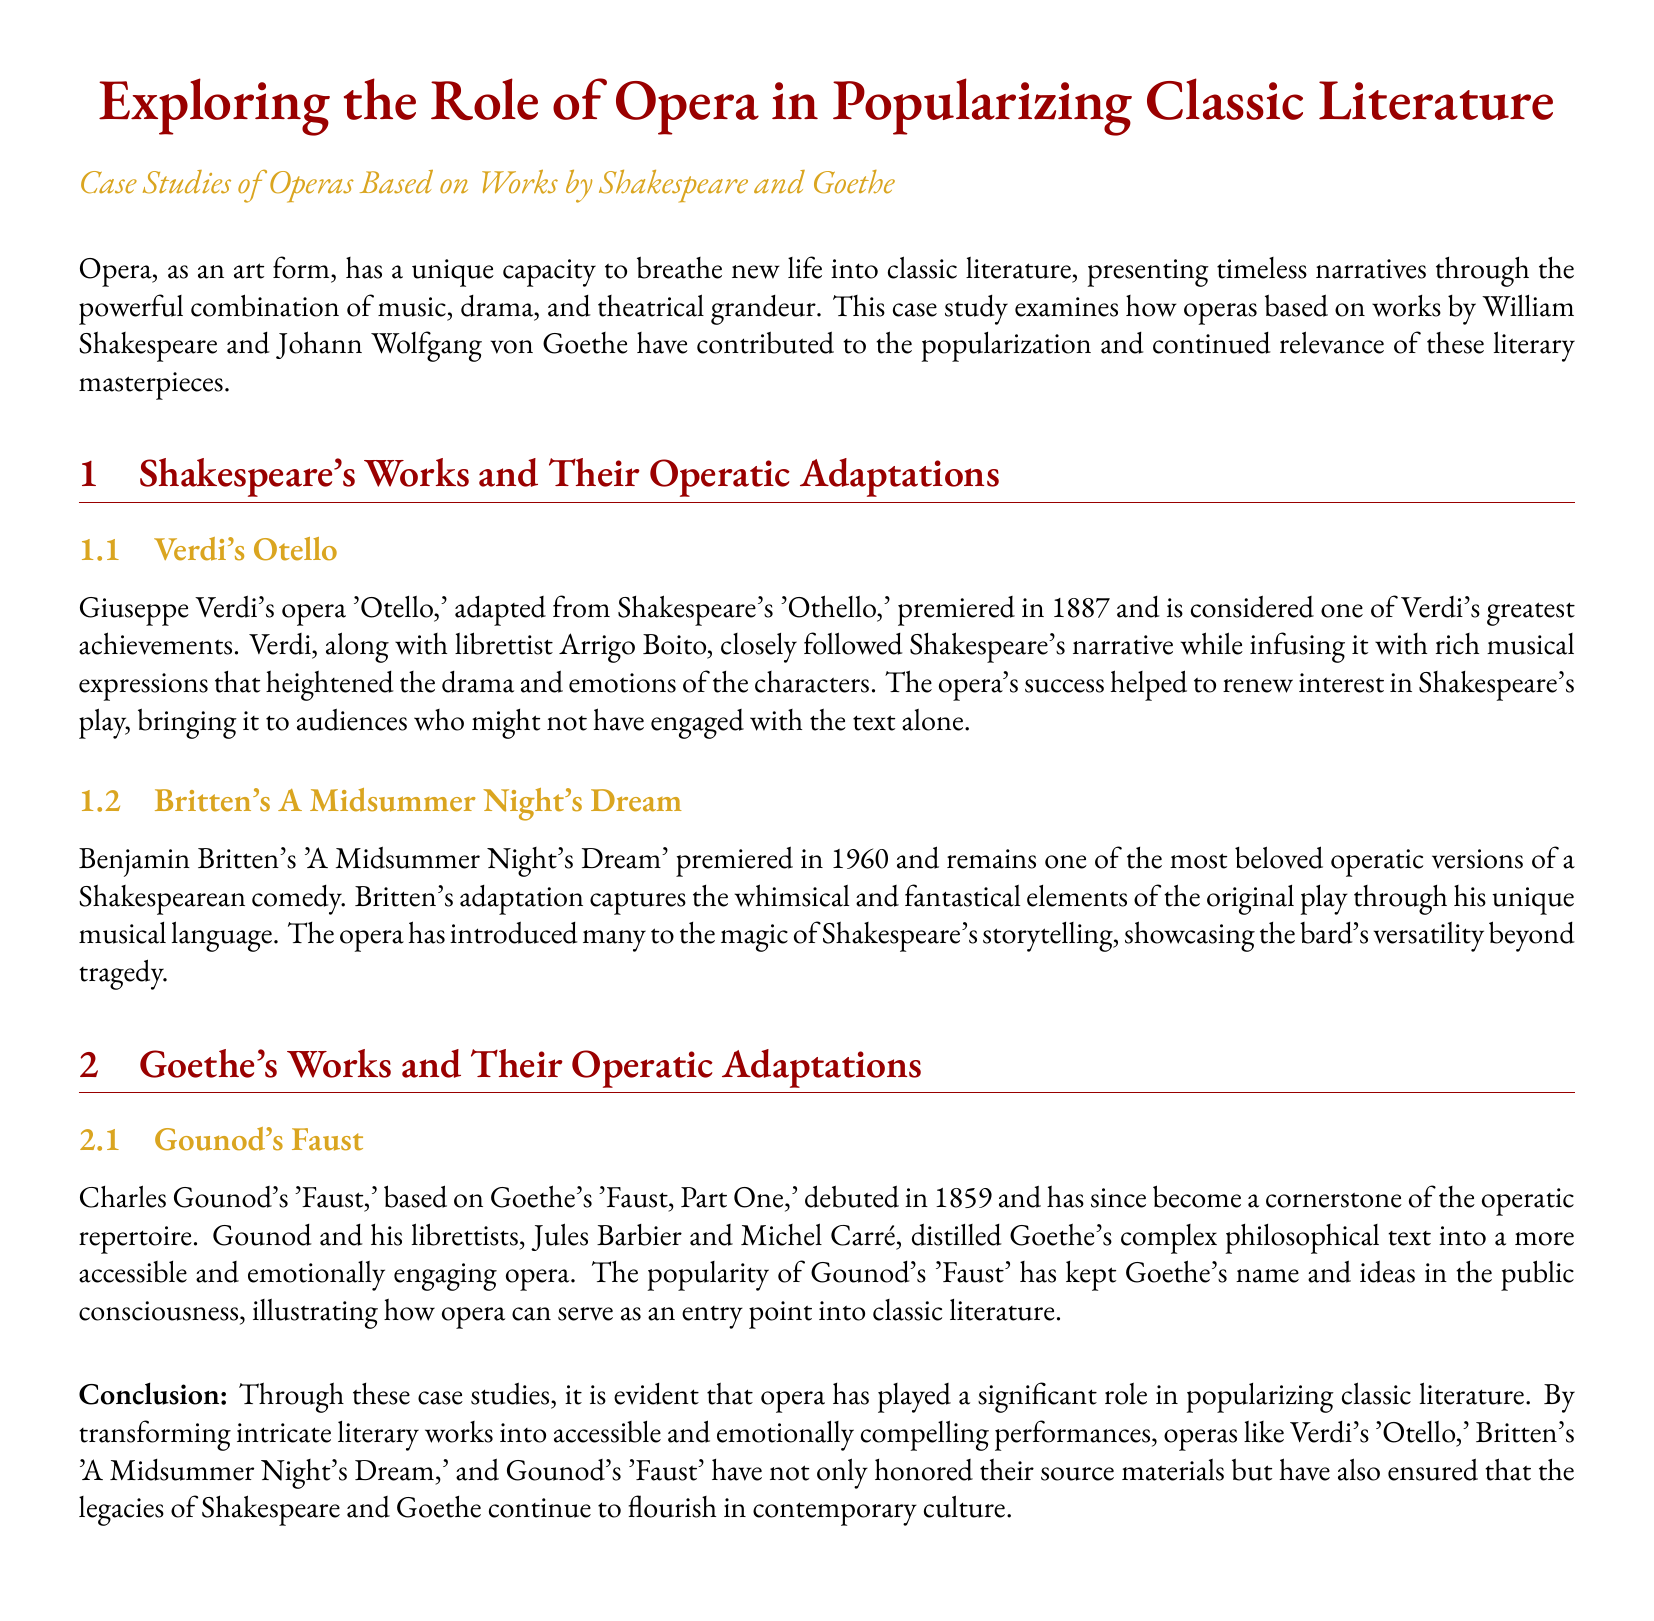What is the title of Verdi's opera adapted from Shakespeare? The title of Verdi's opera is 'Otello,' which is adapted from Shakespeare's 'Othello.'
Answer: 'Otello' When did Gounod's 'Faust' premiere? Gounod's 'Faust' premiered in 1859.
Answer: 1859 Who was the librettist for Verdi's 'Otello'? The librettist for Verdi's 'Otello' was Arrigo Boito.
Answer: Arrigo Boito What type of work is Britten's 'A Midsummer Night's Dream'? Britten's 'A Midsummer Night's Dream' is an operatic version of a Shakespearean comedy.
Answer: operatic version of a Shakespearean comedy How did Gounod adapt Goethe's 'Faust, Part One'? Gounod distilled Goethe's complex philosophical text into a more accessible and emotionally engaging opera.
Answer: more accessible and emotionally engaging opera What does the case study ultimately demonstrate about opera? The case study demonstrates that opera has played a significant role in popularizing classic literature.
Answer: significant role in popularizing classic literature Which literary figures are focused on in the case study? The case study focuses on William Shakespeare and Johann Wolfgang von Goethe.
Answer: William Shakespeare and Johann Wolfgang von Goethe What is the color used for section titles in the document? The color used for section titles in the document is operared.
Answer: operared 